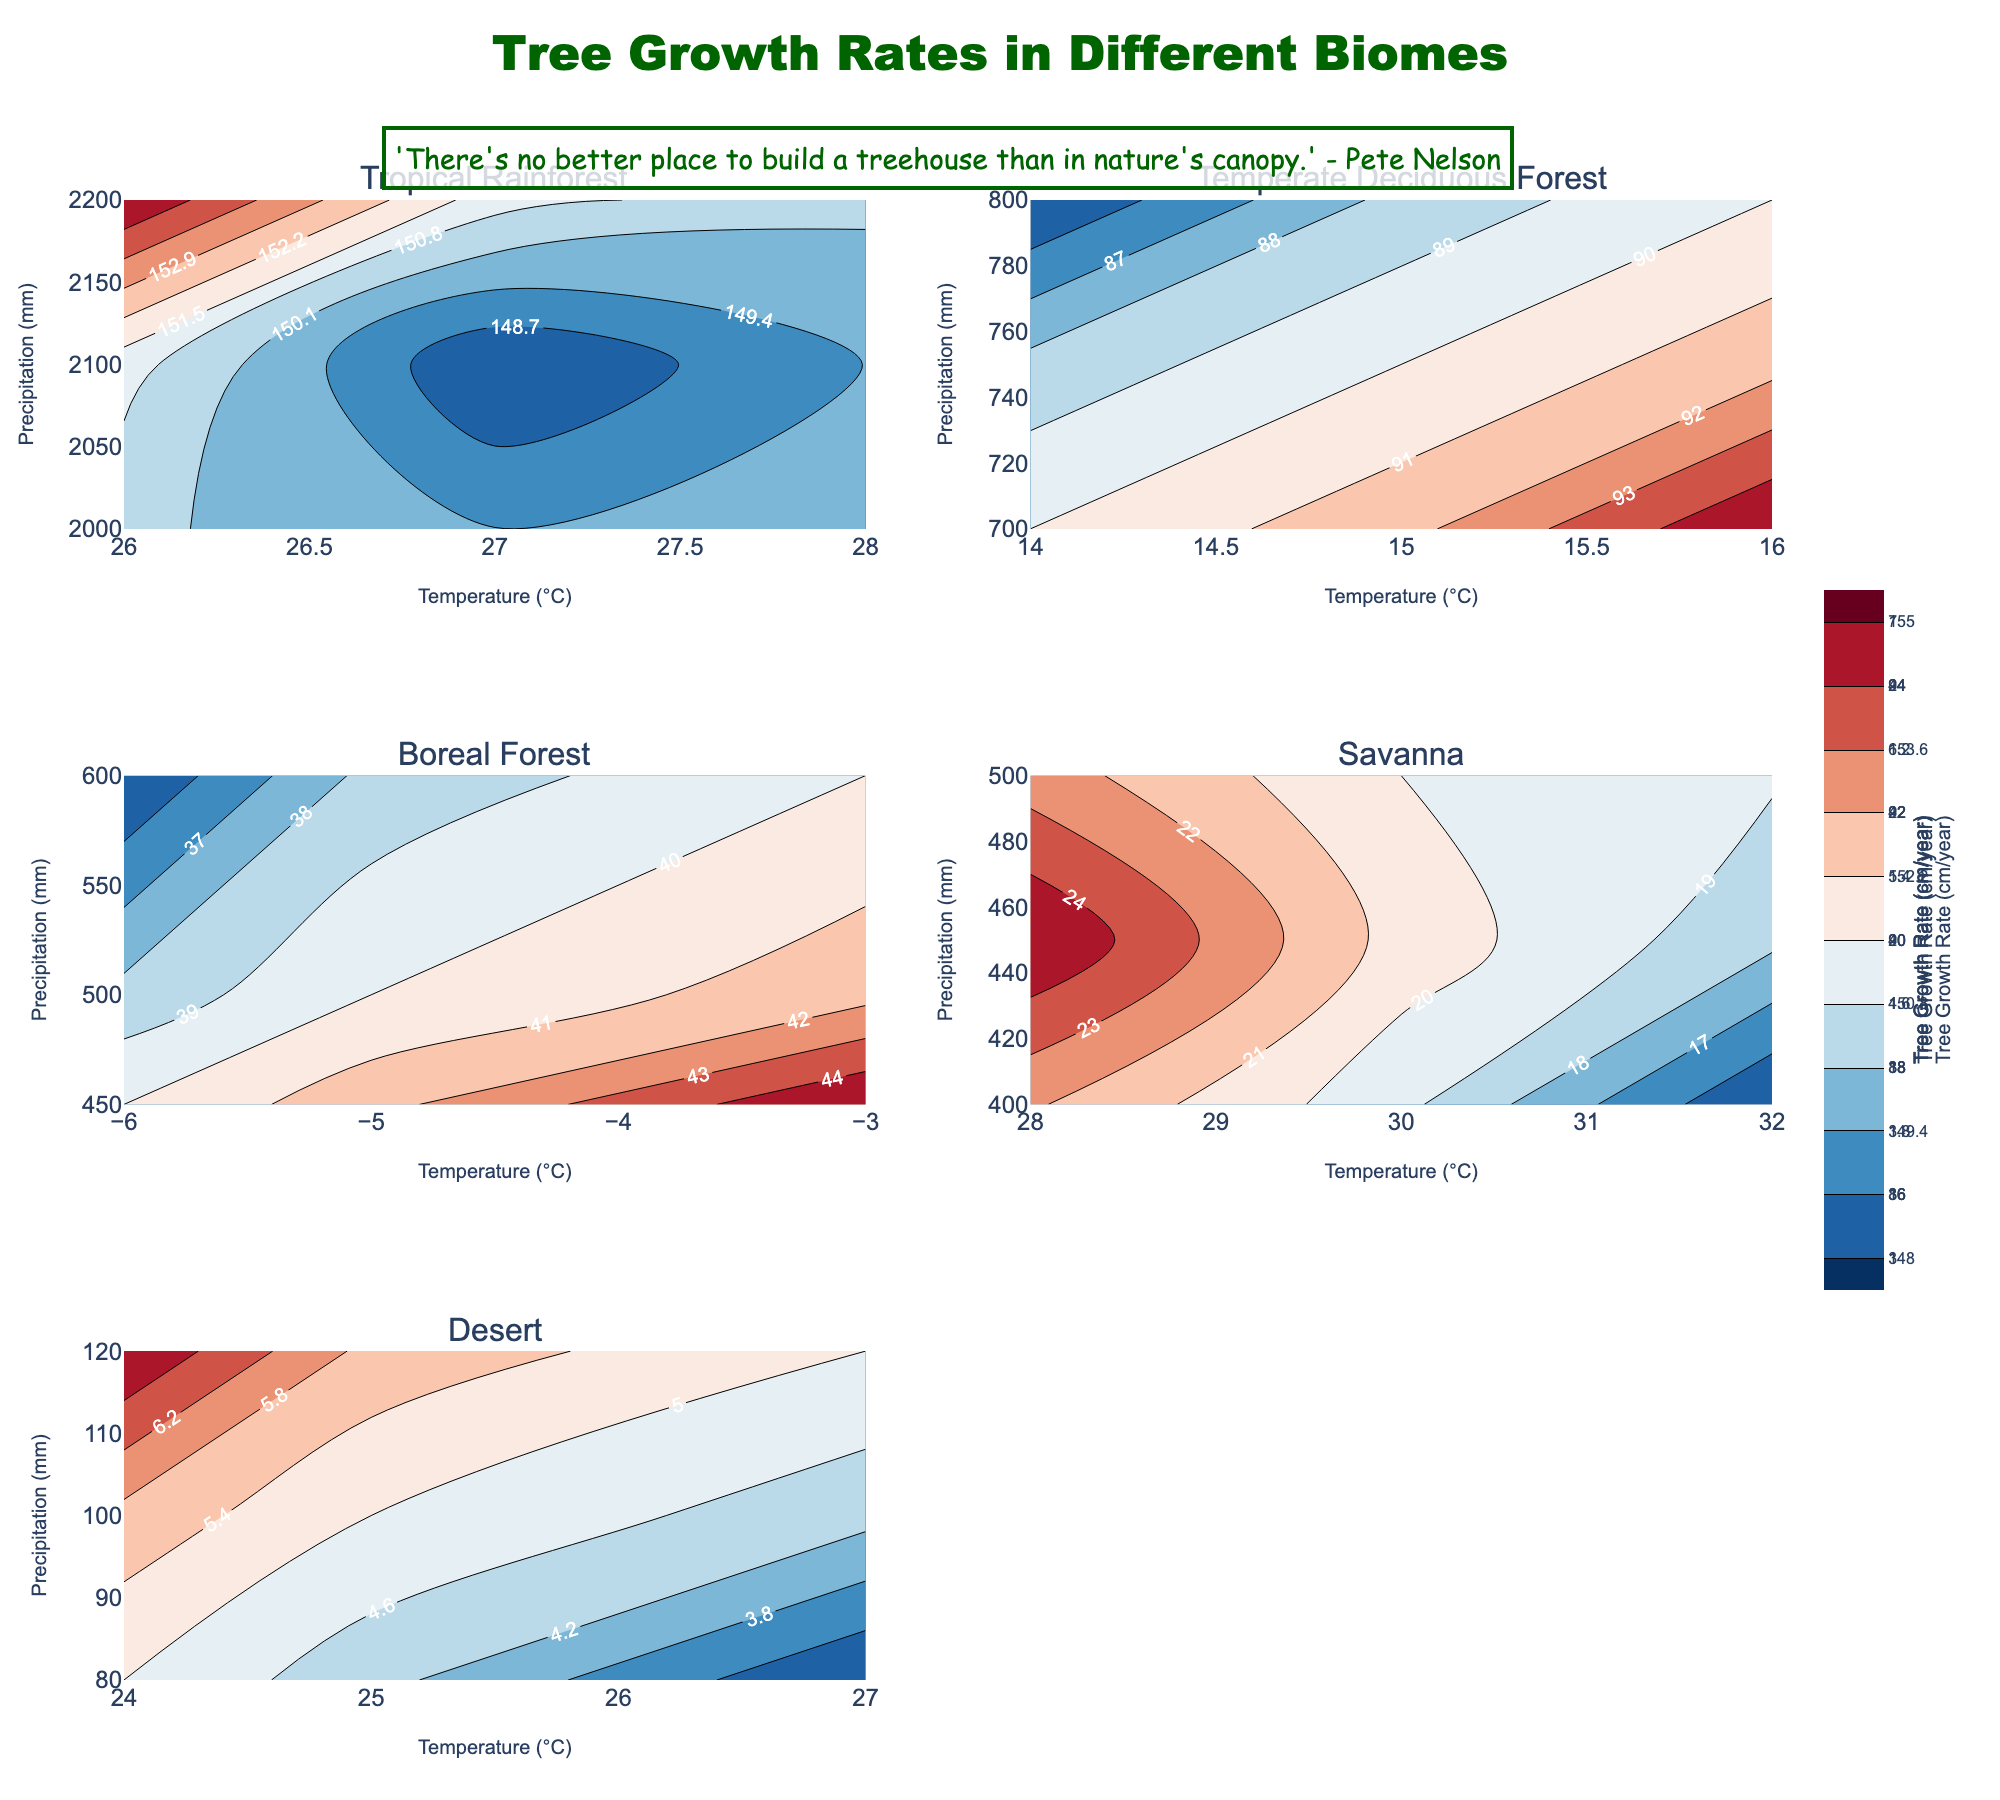What is the title of the figure? The title is located at the top-center of the figure. By referring to the title text in this location, one can read "Tree Growth Rates in Different Biomes".
Answer: "Tree Growth Rates in Different Biomes" Which biome has the highest tree growth rate? By observing the subplots and the color intensity of the contour map, which typically demonstrates higher values with warmer colors like red, we can see that the "Tropical Rainforest" biome presents the highest growth rates.
Answer: "Tropical Rainforest" What is the precipitation range for the "Desert" biome? On the subplot for the Desert biome, examine the y-axis, which represents precipitation (mm). The range extends from the y-minimum of 80 mm to the y-maximum of 120 mm.
Answer: 80 mm to 120 mm How does tree growth rate in the "Savanna" compare to "Boreal Forest"? By comparing the color intensity and contour labels in both the "Savanna" and "Boreal Forest" subplots, we see that "Boreal Forest" has generally higher tree growth rates (around 35-45 cm/year) compared to "Savanna" (around 15-25 cm/year).
Answer: "Boreal Forest" has higher tree growth rates Between which temperature values do the lowest tree growth rates occur for the "Temperate Deciduous Forest" biome? Looking at the "Temperate Deciduous Forest" subplot, finding the range with the coldest colors (indicative of lower values), we see that the lowest tree growth rates are roughly between 14°C and 16°C.
Answer: 14°C and 16°C Which contour line region shows the highest tree growth rates for the "Tropical Rainforest"? In the "Tropical Rainforest" subplot, focus on the contour lines and their labels. The highest tree growth rates are seen around the contour labeled approximately 155 cm/year, which clusters around 26°C and 2200 mm precipitation.
Answer: Around 155 cm/year What's the temperature range with the highest variability in tree growth rates for the "Savanna" biome? By observing the "Savanna" subplot contour map, the area showing a mix of both high and low growth rates colors primarily spans the temperature range of about 30°C to 32°C.
Answer: 30°C to 32°C What is the predominant color for the plot of "Boreal Forest"? The predominant color indicates the average tree growth rate and is found by looking at the "Boreal Forest" subplot. The cooler colors like blue dominate, representing lower growth rates (35-45 cm/year).
Answer: Blue What kind of climate conditions lead to the lowest tree growth rates in the "Desert" biome? In the "Desert" subplot, the lowest tree growth rates are shown by the coolest color (blue shades), which correspond to the combined conditions of 27°C temperature and 80 mm precipitation.
Answer: 27°C temperature, 80 mm precipitation How does precipitation affect tree growth rate in the "Temperate Deciduous Forest"? Observing the "Temperate Deciduous Forest" subplot, one can see a trend where higher precipitation (750-800 mm) correlates with higher tree growth rates (85-95 cm/year) as depicted by warmer colors.
Answer: Higher precipitation leads to higher growth rates 